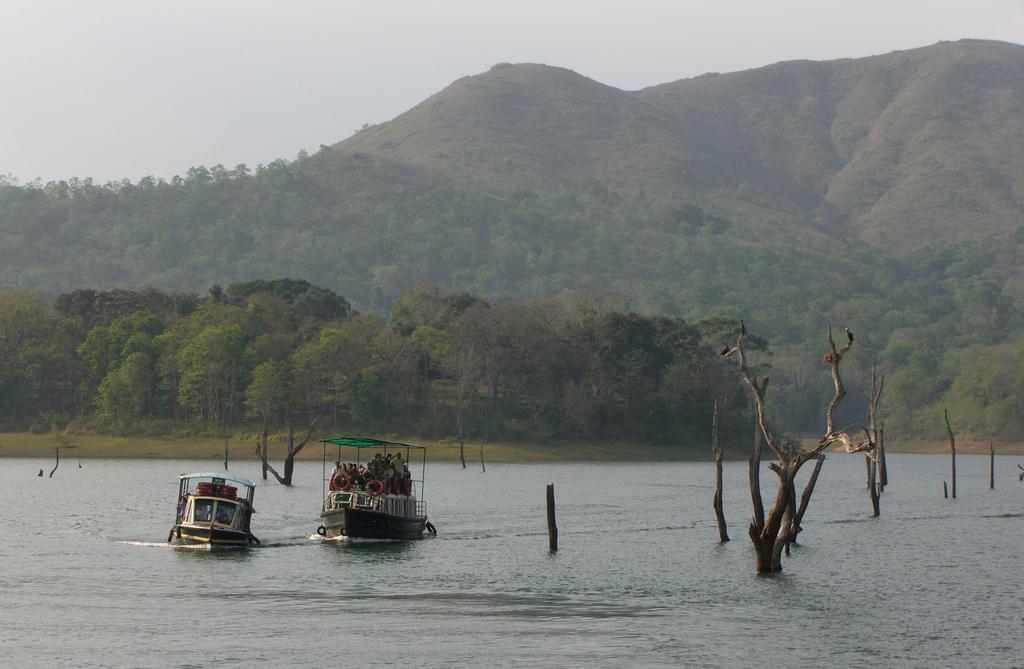Describe this image in one or two sentences. At the bottom of the image there is water. In the water there are some trees. Above the water there are two boats. In the middle of the image there are some trees and hills. At the top of the image there is sky. 